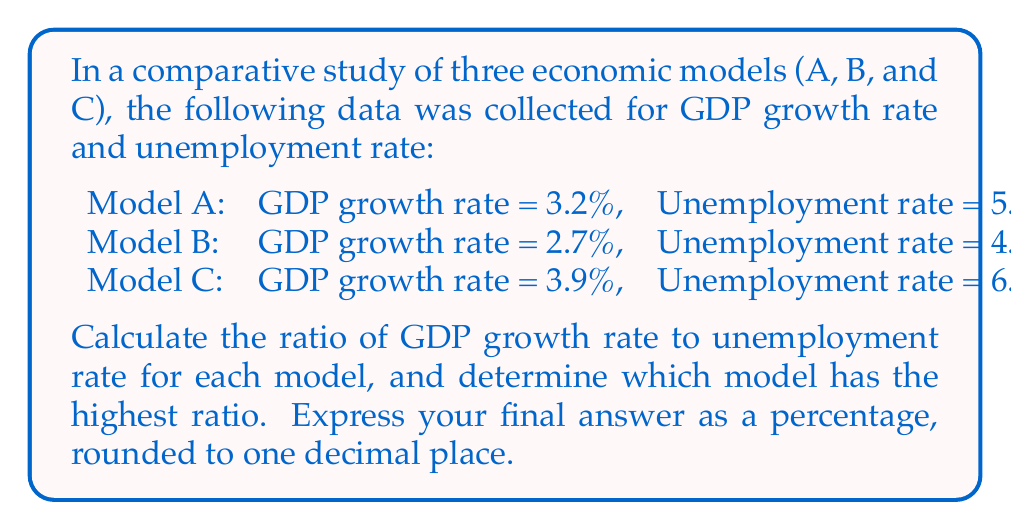Provide a solution to this math problem. To solve this problem, we need to follow these steps:

1. Calculate the ratio of GDP growth rate to unemployment rate for each model.
2. Compare the ratios to determine which model has the highest.
3. Convert the highest ratio to a percentage and round to one decimal place.

Let's calculate the ratios:

For Model A:
$$ \text{Ratio}_A = \frac{\text{GDP growth rate}}{\text{Unemployment rate}} = \frac{3.2}{5.8} \approx 0.5517 $$

For Model B:
$$ \text{Ratio}_B = \frac{\text{GDP growth rate}}{\text{Unemployment rate}} = \frac{2.7}{4.5} = 0.6000 $$

For Model C:
$$ \text{Ratio}_C = \frac{\text{GDP growth rate}}{\text{Unemployment rate}} = \frac{3.9}{6.2} \approx 0.6290 $$

Comparing these ratios, we can see that Model C has the highest ratio at approximately 0.6290.

To express this as a percentage, we multiply by 100:

$$ 0.6290 \times 100 \approx 62.90\% $$

Rounding to one decimal place, we get 62.9%.
Answer: 62.9% 